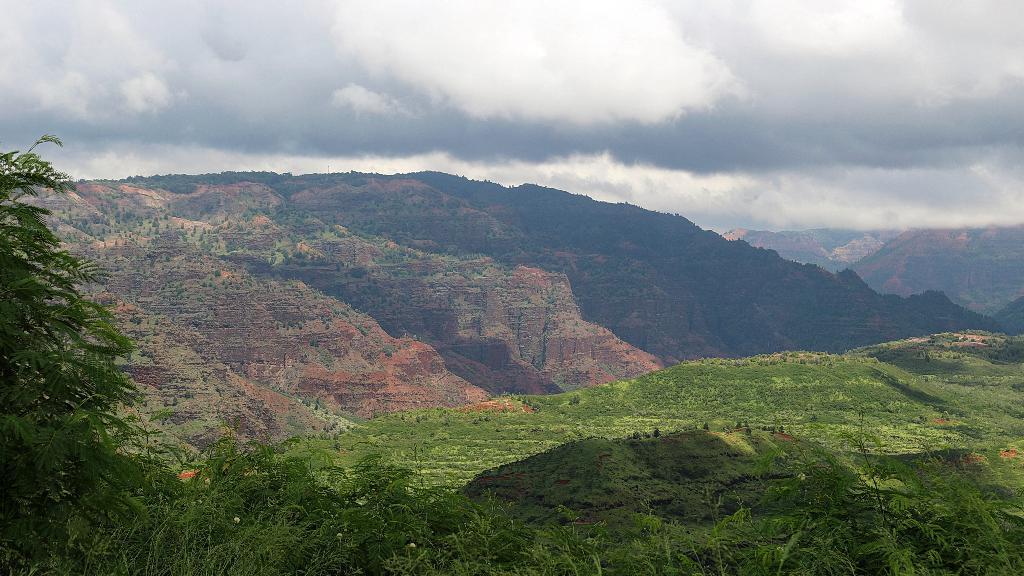In one or two sentences, can you explain what this image depicts? In this image in the front there are plants. In the center there is grass on the ground and in the background there are trees and the sky is cloudy and there are mountains. 